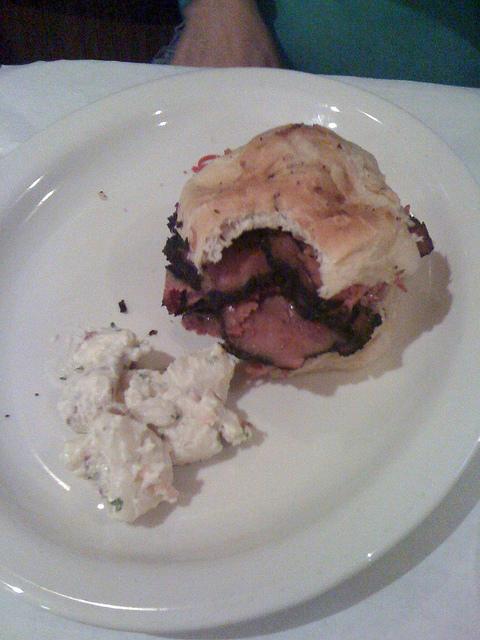Would a vegan eat this?
Keep it brief. No. What color is the plate?
Answer briefly. White. Does the mean in the sandwich appear to be beef or fish?
Concise answer only. Beef. 